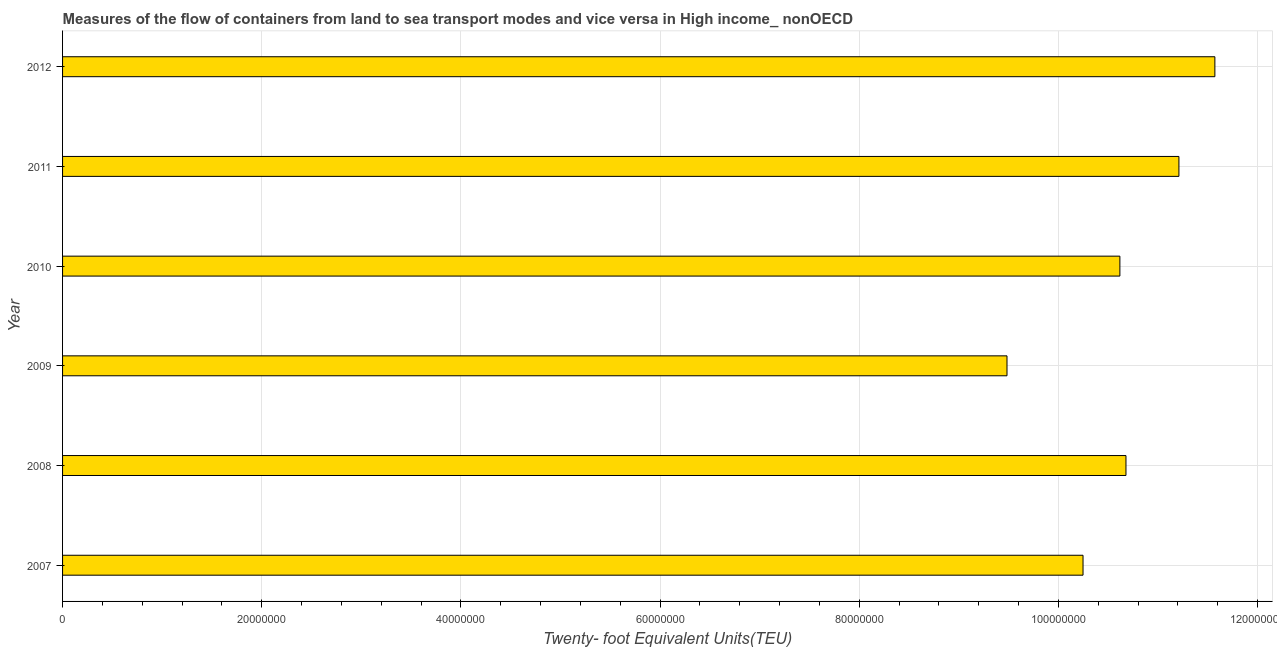Does the graph contain any zero values?
Offer a very short reply. No. What is the title of the graph?
Ensure brevity in your answer.  Measures of the flow of containers from land to sea transport modes and vice versa in High income_ nonOECD. What is the label or title of the X-axis?
Offer a very short reply. Twenty- foot Equivalent Units(TEU). What is the label or title of the Y-axis?
Ensure brevity in your answer.  Year. What is the container port traffic in 2012?
Your answer should be very brief. 1.16e+08. Across all years, what is the maximum container port traffic?
Your answer should be compact. 1.16e+08. Across all years, what is the minimum container port traffic?
Ensure brevity in your answer.  9.48e+07. In which year was the container port traffic minimum?
Your response must be concise. 2009. What is the sum of the container port traffic?
Give a very brief answer. 6.38e+08. What is the difference between the container port traffic in 2009 and 2012?
Provide a short and direct response. -2.09e+07. What is the average container port traffic per year?
Provide a short and direct response. 1.06e+08. What is the median container port traffic?
Your response must be concise. 1.06e+08. In how many years, is the container port traffic greater than 56000000 TEU?
Make the answer very short. 6. What is the ratio of the container port traffic in 2011 to that in 2012?
Offer a terse response. 0.97. What is the difference between the highest and the second highest container port traffic?
Keep it short and to the point. 3.61e+06. What is the difference between the highest and the lowest container port traffic?
Give a very brief answer. 2.09e+07. In how many years, is the container port traffic greater than the average container port traffic taken over all years?
Your response must be concise. 3. How many years are there in the graph?
Offer a terse response. 6. What is the difference between two consecutive major ticks on the X-axis?
Your answer should be compact. 2.00e+07. Are the values on the major ticks of X-axis written in scientific E-notation?
Provide a succinct answer. No. What is the Twenty- foot Equivalent Units(TEU) in 2007?
Offer a terse response. 1.02e+08. What is the Twenty- foot Equivalent Units(TEU) in 2008?
Offer a terse response. 1.07e+08. What is the Twenty- foot Equivalent Units(TEU) of 2009?
Keep it short and to the point. 9.48e+07. What is the Twenty- foot Equivalent Units(TEU) in 2010?
Your answer should be very brief. 1.06e+08. What is the Twenty- foot Equivalent Units(TEU) of 2011?
Your response must be concise. 1.12e+08. What is the Twenty- foot Equivalent Units(TEU) in 2012?
Provide a short and direct response. 1.16e+08. What is the difference between the Twenty- foot Equivalent Units(TEU) in 2007 and 2008?
Your response must be concise. -4.31e+06. What is the difference between the Twenty- foot Equivalent Units(TEU) in 2007 and 2009?
Your answer should be compact. 7.63e+06. What is the difference between the Twenty- foot Equivalent Units(TEU) in 2007 and 2010?
Provide a succinct answer. -3.70e+06. What is the difference between the Twenty- foot Equivalent Units(TEU) in 2007 and 2011?
Provide a succinct answer. -9.63e+06. What is the difference between the Twenty- foot Equivalent Units(TEU) in 2007 and 2012?
Provide a succinct answer. -1.32e+07. What is the difference between the Twenty- foot Equivalent Units(TEU) in 2008 and 2009?
Make the answer very short. 1.19e+07. What is the difference between the Twenty- foot Equivalent Units(TEU) in 2008 and 2010?
Ensure brevity in your answer.  6.11e+05. What is the difference between the Twenty- foot Equivalent Units(TEU) in 2008 and 2011?
Provide a short and direct response. -5.32e+06. What is the difference between the Twenty- foot Equivalent Units(TEU) in 2008 and 2012?
Provide a short and direct response. -8.93e+06. What is the difference between the Twenty- foot Equivalent Units(TEU) in 2009 and 2010?
Provide a succinct answer. -1.13e+07. What is the difference between the Twenty- foot Equivalent Units(TEU) in 2009 and 2011?
Provide a succinct answer. -1.73e+07. What is the difference between the Twenty- foot Equivalent Units(TEU) in 2009 and 2012?
Keep it short and to the point. -2.09e+07. What is the difference between the Twenty- foot Equivalent Units(TEU) in 2010 and 2011?
Keep it short and to the point. -5.93e+06. What is the difference between the Twenty- foot Equivalent Units(TEU) in 2010 and 2012?
Offer a terse response. -9.54e+06. What is the difference between the Twenty- foot Equivalent Units(TEU) in 2011 and 2012?
Your response must be concise. -3.61e+06. What is the ratio of the Twenty- foot Equivalent Units(TEU) in 2007 to that in 2008?
Offer a very short reply. 0.96. What is the ratio of the Twenty- foot Equivalent Units(TEU) in 2007 to that in 2011?
Your answer should be compact. 0.91. What is the ratio of the Twenty- foot Equivalent Units(TEU) in 2007 to that in 2012?
Offer a very short reply. 0.89. What is the ratio of the Twenty- foot Equivalent Units(TEU) in 2008 to that in 2009?
Your answer should be compact. 1.13. What is the ratio of the Twenty- foot Equivalent Units(TEU) in 2008 to that in 2011?
Your answer should be very brief. 0.95. What is the ratio of the Twenty- foot Equivalent Units(TEU) in 2008 to that in 2012?
Make the answer very short. 0.92. What is the ratio of the Twenty- foot Equivalent Units(TEU) in 2009 to that in 2010?
Provide a succinct answer. 0.89. What is the ratio of the Twenty- foot Equivalent Units(TEU) in 2009 to that in 2011?
Make the answer very short. 0.85. What is the ratio of the Twenty- foot Equivalent Units(TEU) in 2009 to that in 2012?
Give a very brief answer. 0.82. What is the ratio of the Twenty- foot Equivalent Units(TEU) in 2010 to that in 2011?
Offer a terse response. 0.95. What is the ratio of the Twenty- foot Equivalent Units(TEU) in 2010 to that in 2012?
Your answer should be very brief. 0.92. 